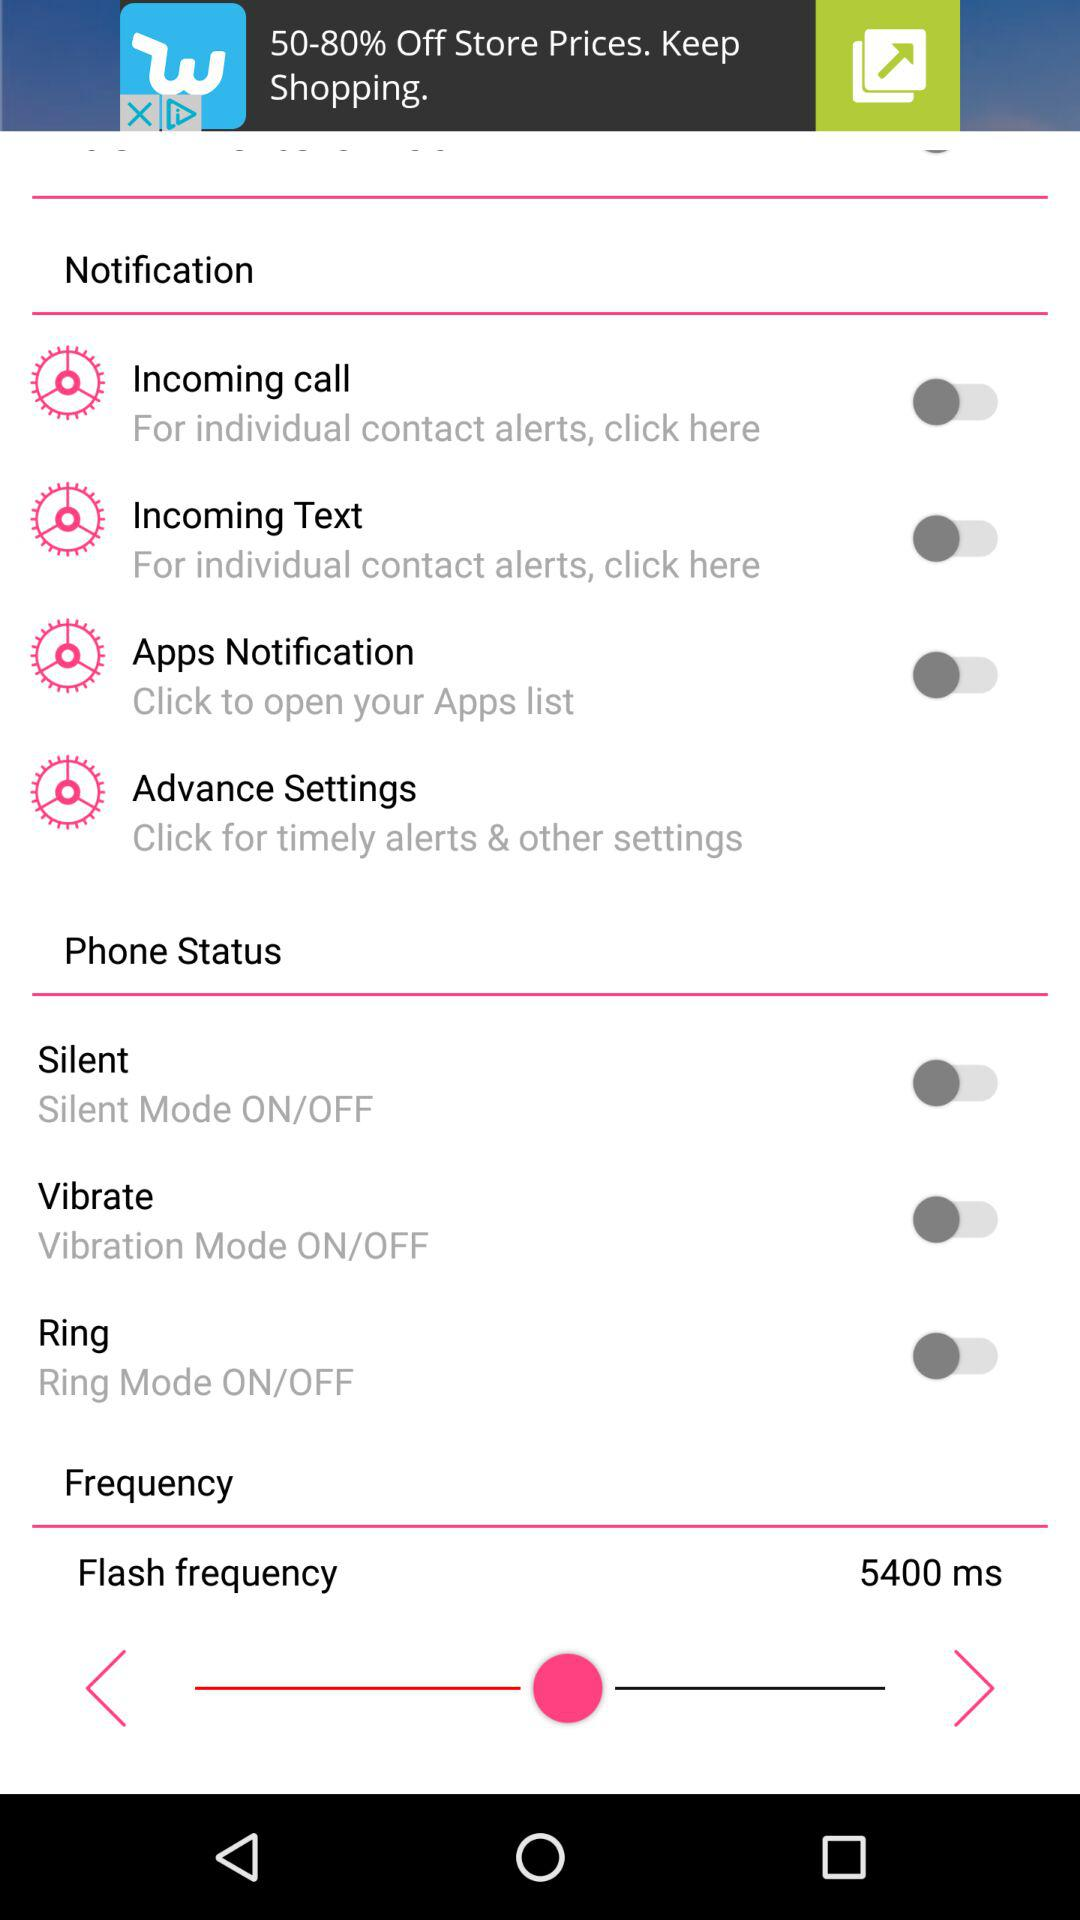What is the status of "Silent"? The status is "off". 